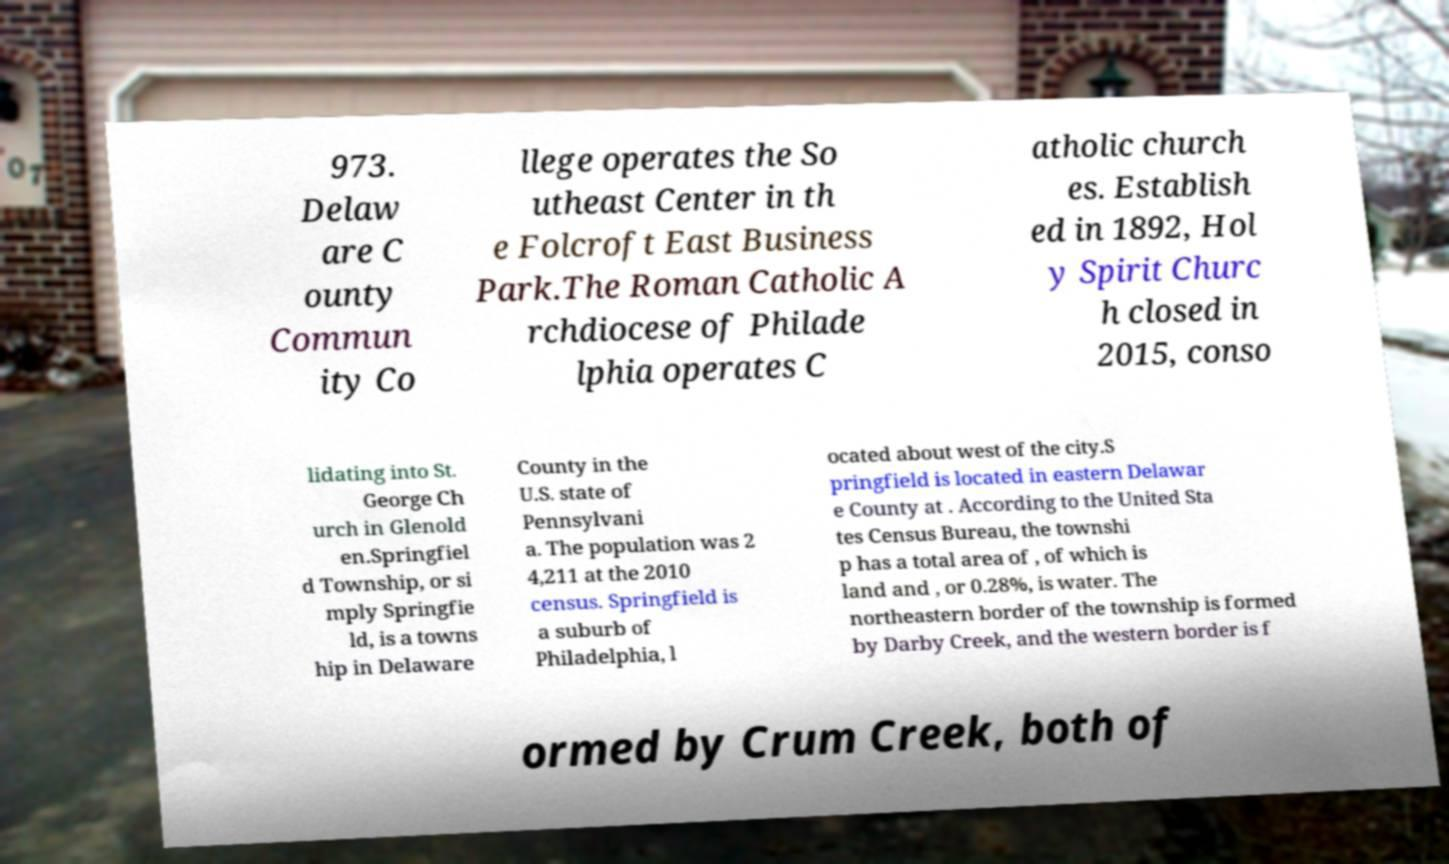Can you read and provide the text displayed in the image?This photo seems to have some interesting text. Can you extract and type it out for me? 973. Delaw are C ounty Commun ity Co llege operates the So utheast Center in th e Folcroft East Business Park.The Roman Catholic A rchdiocese of Philade lphia operates C atholic church es. Establish ed in 1892, Hol y Spirit Churc h closed in 2015, conso lidating into St. George Ch urch in Glenold en.Springfiel d Township, or si mply Springfie ld, is a towns hip in Delaware County in the U.S. state of Pennsylvani a. The population was 2 4,211 at the 2010 census. Springfield is a suburb of Philadelphia, l ocated about west of the city.S pringfield is located in eastern Delawar e County at . According to the United Sta tes Census Bureau, the townshi p has a total area of , of which is land and , or 0.28%, is water. The northeastern border of the township is formed by Darby Creek, and the western border is f ormed by Crum Creek, both of 